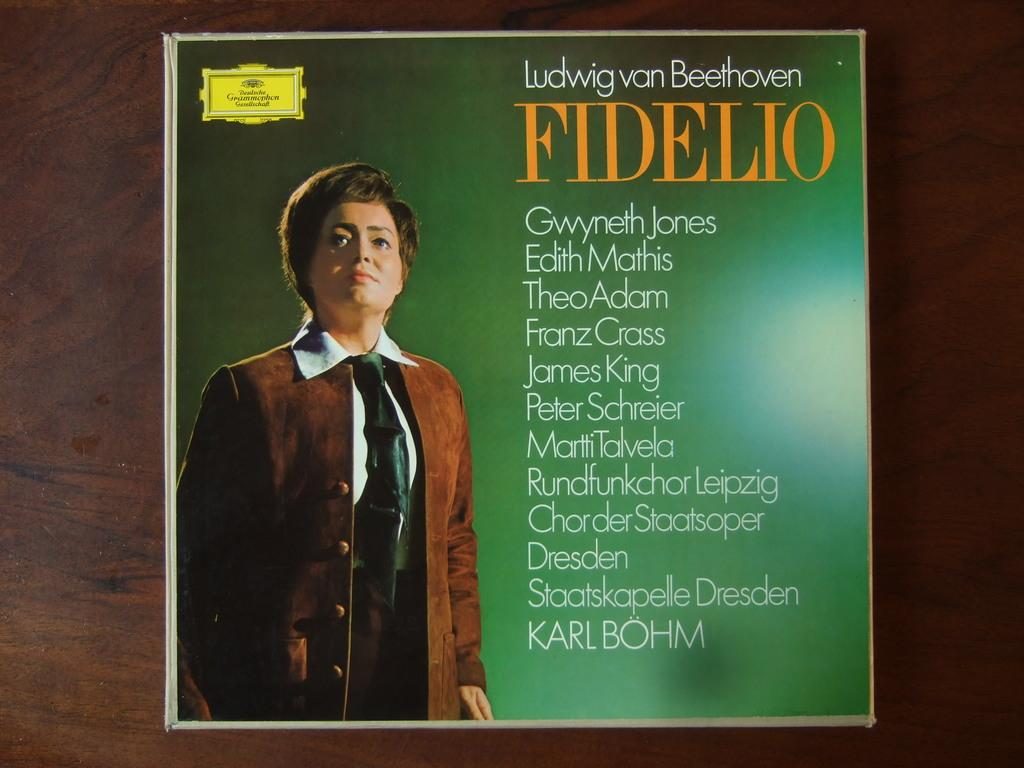Provide a one-sentence caption for the provided image. A Ludwig van Beethoven record sitting on a wooden table. 